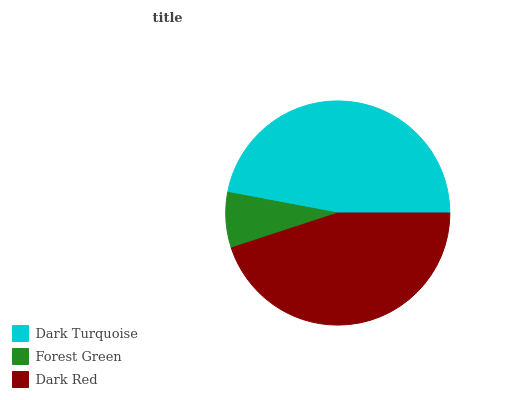Is Forest Green the minimum?
Answer yes or no. Yes. Is Dark Turquoise the maximum?
Answer yes or no. Yes. Is Dark Red the minimum?
Answer yes or no. No. Is Dark Red the maximum?
Answer yes or no. No. Is Dark Red greater than Forest Green?
Answer yes or no. Yes. Is Forest Green less than Dark Red?
Answer yes or no. Yes. Is Forest Green greater than Dark Red?
Answer yes or no. No. Is Dark Red less than Forest Green?
Answer yes or no. No. Is Dark Red the high median?
Answer yes or no. Yes. Is Dark Red the low median?
Answer yes or no. Yes. Is Dark Turquoise the high median?
Answer yes or no. No. Is Dark Turquoise the low median?
Answer yes or no. No. 